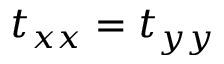<formula> <loc_0><loc_0><loc_500><loc_500>t _ { x x } = t _ { y y }</formula> 